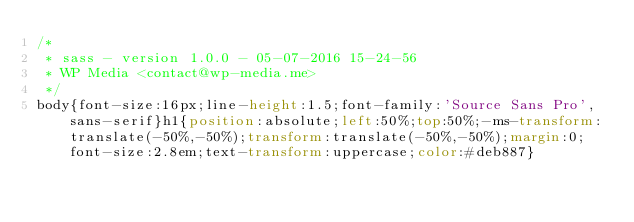<code> <loc_0><loc_0><loc_500><loc_500><_CSS_>/*
 * sass - version 1.0.0 - 05-07-2016 15-24-56
 * WP Media <contact@wp-media.me>
 */
body{font-size:16px;line-height:1.5;font-family:'Source Sans Pro',sans-serif}h1{position:absolute;left:50%;top:50%;-ms-transform:translate(-50%,-50%);transform:translate(-50%,-50%);margin:0;font-size:2.8em;text-transform:uppercase;color:#deb887}</code> 